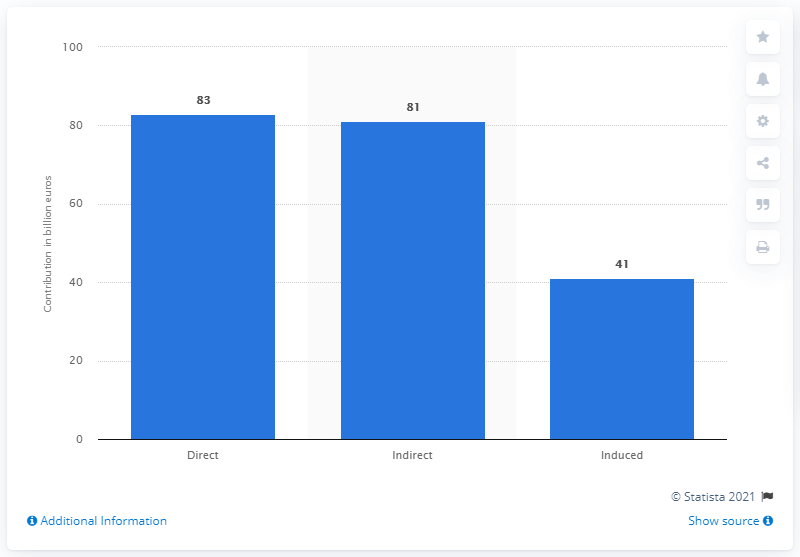Highlight a few significant elements in this photo. In 2017, the travel and tourism industry contributed a significant amount to the French economy, amounting to 83... 